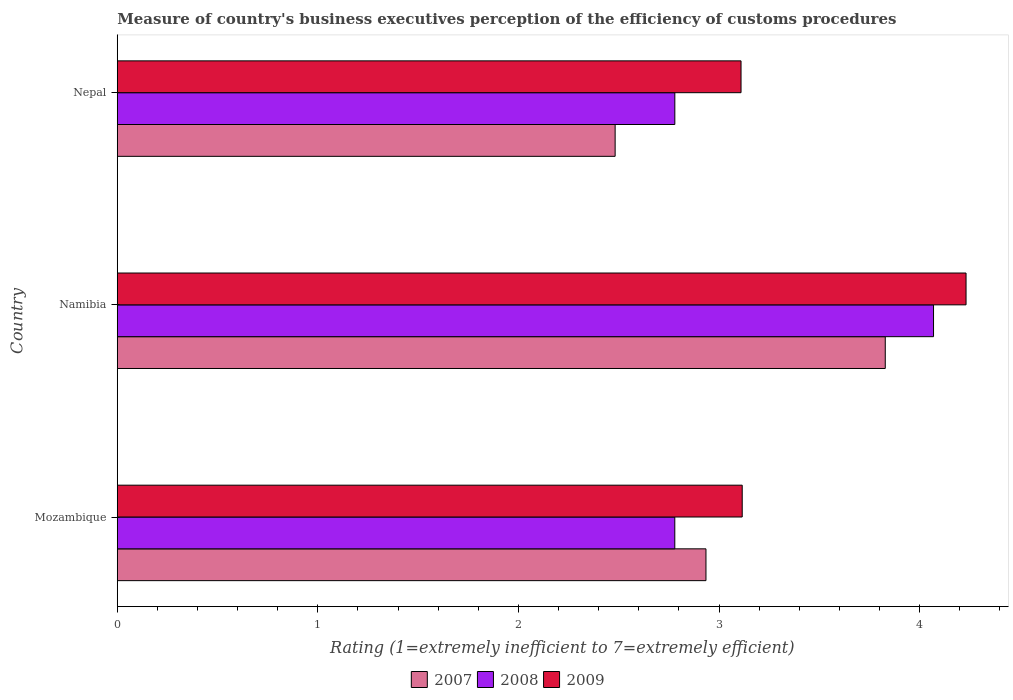How many different coloured bars are there?
Provide a short and direct response. 3. Are the number of bars per tick equal to the number of legend labels?
Provide a short and direct response. Yes. What is the label of the 2nd group of bars from the top?
Your answer should be compact. Namibia. What is the rating of the efficiency of customs procedure in 2009 in Nepal?
Your answer should be very brief. 3.11. Across all countries, what is the maximum rating of the efficiency of customs procedure in 2007?
Provide a succinct answer. 3.83. Across all countries, what is the minimum rating of the efficiency of customs procedure in 2007?
Give a very brief answer. 2.48. In which country was the rating of the efficiency of customs procedure in 2009 maximum?
Keep it short and to the point. Namibia. In which country was the rating of the efficiency of customs procedure in 2008 minimum?
Your answer should be compact. Mozambique. What is the total rating of the efficiency of customs procedure in 2007 in the graph?
Provide a short and direct response. 9.25. What is the difference between the rating of the efficiency of customs procedure in 2008 in Mozambique and that in Namibia?
Give a very brief answer. -1.29. What is the difference between the rating of the efficiency of customs procedure in 2008 in Namibia and the rating of the efficiency of customs procedure in 2009 in Mozambique?
Provide a short and direct response. 0.95. What is the average rating of the efficiency of customs procedure in 2009 per country?
Your response must be concise. 3.49. What is the difference between the rating of the efficiency of customs procedure in 2008 and rating of the efficiency of customs procedure in 2009 in Nepal?
Your answer should be compact. -0.33. What is the ratio of the rating of the efficiency of customs procedure in 2008 in Mozambique to that in Namibia?
Keep it short and to the point. 0.68. What is the difference between the highest and the second highest rating of the efficiency of customs procedure in 2009?
Provide a succinct answer. 1.12. What is the difference between the highest and the lowest rating of the efficiency of customs procedure in 2007?
Your answer should be compact. 1.35. In how many countries, is the rating of the efficiency of customs procedure in 2008 greater than the average rating of the efficiency of customs procedure in 2008 taken over all countries?
Your response must be concise. 1. What does the 2nd bar from the top in Nepal represents?
Offer a terse response. 2008. What does the 1st bar from the bottom in Namibia represents?
Ensure brevity in your answer.  2007. Is it the case that in every country, the sum of the rating of the efficiency of customs procedure in 2008 and rating of the efficiency of customs procedure in 2009 is greater than the rating of the efficiency of customs procedure in 2007?
Keep it short and to the point. Yes. How many bars are there?
Your answer should be compact. 9. How many countries are there in the graph?
Provide a succinct answer. 3. What is the difference between two consecutive major ticks on the X-axis?
Make the answer very short. 1. Does the graph contain grids?
Your answer should be compact. No. Where does the legend appear in the graph?
Give a very brief answer. Bottom center. What is the title of the graph?
Provide a succinct answer. Measure of country's business executives perception of the efficiency of customs procedures. Does "1991" appear as one of the legend labels in the graph?
Your answer should be compact. No. What is the label or title of the X-axis?
Keep it short and to the point. Rating (1=extremely inefficient to 7=extremely efficient). What is the label or title of the Y-axis?
Keep it short and to the point. Country. What is the Rating (1=extremely inefficient to 7=extremely efficient) in 2007 in Mozambique?
Ensure brevity in your answer.  2.93. What is the Rating (1=extremely inefficient to 7=extremely efficient) of 2008 in Mozambique?
Keep it short and to the point. 2.78. What is the Rating (1=extremely inefficient to 7=extremely efficient) of 2009 in Mozambique?
Your answer should be very brief. 3.12. What is the Rating (1=extremely inefficient to 7=extremely efficient) of 2007 in Namibia?
Provide a short and direct response. 3.83. What is the Rating (1=extremely inefficient to 7=extremely efficient) in 2008 in Namibia?
Offer a very short reply. 4.07. What is the Rating (1=extremely inefficient to 7=extremely efficient) in 2009 in Namibia?
Keep it short and to the point. 4.23. What is the Rating (1=extremely inefficient to 7=extremely efficient) of 2007 in Nepal?
Offer a terse response. 2.48. What is the Rating (1=extremely inefficient to 7=extremely efficient) of 2008 in Nepal?
Your answer should be compact. 2.78. What is the Rating (1=extremely inefficient to 7=extremely efficient) in 2009 in Nepal?
Make the answer very short. 3.11. Across all countries, what is the maximum Rating (1=extremely inefficient to 7=extremely efficient) in 2007?
Make the answer very short. 3.83. Across all countries, what is the maximum Rating (1=extremely inefficient to 7=extremely efficient) in 2008?
Your answer should be compact. 4.07. Across all countries, what is the maximum Rating (1=extremely inefficient to 7=extremely efficient) of 2009?
Offer a very short reply. 4.23. Across all countries, what is the minimum Rating (1=extremely inefficient to 7=extremely efficient) in 2007?
Provide a short and direct response. 2.48. Across all countries, what is the minimum Rating (1=extremely inefficient to 7=extremely efficient) in 2008?
Offer a terse response. 2.78. Across all countries, what is the minimum Rating (1=extremely inefficient to 7=extremely efficient) in 2009?
Make the answer very short. 3.11. What is the total Rating (1=extremely inefficient to 7=extremely efficient) of 2007 in the graph?
Provide a succinct answer. 9.25. What is the total Rating (1=extremely inefficient to 7=extremely efficient) of 2008 in the graph?
Offer a terse response. 9.63. What is the total Rating (1=extremely inefficient to 7=extremely efficient) of 2009 in the graph?
Offer a terse response. 10.46. What is the difference between the Rating (1=extremely inefficient to 7=extremely efficient) in 2007 in Mozambique and that in Namibia?
Make the answer very short. -0.89. What is the difference between the Rating (1=extremely inefficient to 7=extremely efficient) of 2008 in Mozambique and that in Namibia?
Offer a very short reply. -1.29. What is the difference between the Rating (1=extremely inefficient to 7=extremely efficient) in 2009 in Mozambique and that in Namibia?
Provide a short and direct response. -1.12. What is the difference between the Rating (1=extremely inefficient to 7=extremely efficient) of 2007 in Mozambique and that in Nepal?
Offer a very short reply. 0.45. What is the difference between the Rating (1=extremely inefficient to 7=extremely efficient) in 2008 in Mozambique and that in Nepal?
Make the answer very short. -0. What is the difference between the Rating (1=extremely inefficient to 7=extremely efficient) in 2009 in Mozambique and that in Nepal?
Ensure brevity in your answer.  0.01. What is the difference between the Rating (1=extremely inefficient to 7=extremely efficient) of 2007 in Namibia and that in Nepal?
Offer a very short reply. 1.35. What is the difference between the Rating (1=extremely inefficient to 7=extremely efficient) of 2008 in Namibia and that in Nepal?
Your response must be concise. 1.29. What is the difference between the Rating (1=extremely inefficient to 7=extremely efficient) in 2009 in Namibia and that in Nepal?
Your response must be concise. 1.12. What is the difference between the Rating (1=extremely inefficient to 7=extremely efficient) in 2007 in Mozambique and the Rating (1=extremely inefficient to 7=extremely efficient) in 2008 in Namibia?
Give a very brief answer. -1.13. What is the difference between the Rating (1=extremely inefficient to 7=extremely efficient) of 2007 in Mozambique and the Rating (1=extremely inefficient to 7=extremely efficient) of 2009 in Namibia?
Your response must be concise. -1.3. What is the difference between the Rating (1=extremely inefficient to 7=extremely efficient) in 2008 in Mozambique and the Rating (1=extremely inefficient to 7=extremely efficient) in 2009 in Namibia?
Offer a very short reply. -1.45. What is the difference between the Rating (1=extremely inefficient to 7=extremely efficient) of 2007 in Mozambique and the Rating (1=extremely inefficient to 7=extremely efficient) of 2008 in Nepal?
Keep it short and to the point. 0.16. What is the difference between the Rating (1=extremely inefficient to 7=extremely efficient) in 2007 in Mozambique and the Rating (1=extremely inefficient to 7=extremely efficient) in 2009 in Nepal?
Keep it short and to the point. -0.17. What is the difference between the Rating (1=extremely inefficient to 7=extremely efficient) of 2008 in Mozambique and the Rating (1=extremely inefficient to 7=extremely efficient) of 2009 in Nepal?
Make the answer very short. -0.33. What is the difference between the Rating (1=extremely inefficient to 7=extremely efficient) in 2007 in Namibia and the Rating (1=extremely inefficient to 7=extremely efficient) in 2008 in Nepal?
Provide a short and direct response. 1.05. What is the difference between the Rating (1=extremely inefficient to 7=extremely efficient) of 2007 in Namibia and the Rating (1=extremely inefficient to 7=extremely efficient) of 2009 in Nepal?
Provide a succinct answer. 0.72. What is the difference between the Rating (1=extremely inefficient to 7=extremely efficient) in 2008 in Namibia and the Rating (1=extremely inefficient to 7=extremely efficient) in 2009 in Nepal?
Offer a terse response. 0.96. What is the average Rating (1=extremely inefficient to 7=extremely efficient) of 2007 per country?
Offer a very short reply. 3.08. What is the average Rating (1=extremely inefficient to 7=extremely efficient) in 2008 per country?
Keep it short and to the point. 3.21. What is the average Rating (1=extremely inefficient to 7=extremely efficient) in 2009 per country?
Provide a short and direct response. 3.49. What is the difference between the Rating (1=extremely inefficient to 7=extremely efficient) of 2007 and Rating (1=extremely inefficient to 7=extremely efficient) of 2008 in Mozambique?
Keep it short and to the point. 0.16. What is the difference between the Rating (1=extremely inefficient to 7=extremely efficient) of 2007 and Rating (1=extremely inefficient to 7=extremely efficient) of 2009 in Mozambique?
Make the answer very short. -0.18. What is the difference between the Rating (1=extremely inefficient to 7=extremely efficient) of 2008 and Rating (1=extremely inefficient to 7=extremely efficient) of 2009 in Mozambique?
Offer a terse response. -0.34. What is the difference between the Rating (1=extremely inefficient to 7=extremely efficient) in 2007 and Rating (1=extremely inefficient to 7=extremely efficient) in 2008 in Namibia?
Ensure brevity in your answer.  -0.24. What is the difference between the Rating (1=extremely inefficient to 7=extremely efficient) in 2007 and Rating (1=extremely inefficient to 7=extremely efficient) in 2009 in Namibia?
Offer a terse response. -0.4. What is the difference between the Rating (1=extremely inefficient to 7=extremely efficient) of 2008 and Rating (1=extremely inefficient to 7=extremely efficient) of 2009 in Namibia?
Keep it short and to the point. -0.16. What is the difference between the Rating (1=extremely inefficient to 7=extremely efficient) in 2007 and Rating (1=extremely inefficient to 7=extremely efficient) in 2008 in Nepal?
Your answer should be compact. -0.3. What is the difference between the Rating (1=extremely inefficient to 7=extremely efficient) in 2007 and Rating (1=extremely inefficient to 7=extremely efficient) in 2009 in Nepal?
Provide a succinct answer. -0.63. What is the difference between the Rating (1=extremely inefficient to 7=extremely efficient) of 2008 and Rating (1=extremely inefficient to 7=extremely efficient) of 2009 in Nepal?
Keep it short and to the point. -0.33. What is the ratio of the Rating (1=extremely inefficient to 7=extremely efficient) in 2007 in Mozambique to that in Namibia?
Give a very brief answer. 0.77. What is the ratio of the Rating (1=extremely inefficient to 7=extremely efficient) in 2008 in Mozambique to that in Namibia?
Make the answer very short. 0.68. What is the ratio of the Rating (1=extremely inefficient to 7=extremely efficient) of 2009 in Mozambique to that in Namibia?
Give a very brief answer. 0.74. What is the ratio of the Rating (1=extremely inefficient to 7=extremely efficient) of 2007 in Mozambique to that in Nepal?
Your answer should be very brief. 1.18. What is the ratio of the Rating (1=extremely inefficient to 7=extremely efficient) of 2007 in Namibia to that in Nepal?
Provide a short and direct response. 1.54. What is the ratio of the Rating (1=extremely inefficient to 7=extremely efficient) in 2008 in Namibia to that in Nepal?
Give a very brief answer. 1.46. What is the ratio of the Rating (1=extremely inefficient to 7=extremely efficient) of 2009 in Namibia to that in Nepal?
Ensure brevity in your answer.  1.36. What is the difference between the highest and the second highest Rating (1=extremely inefficient to 7=extremely efficient) in 2007?
Your answer should be very brief. 0.89. What is the difference between the highest and the second highest Rating (1=extremely inefficient to 7=extremely efficient) in 2008?
Ensure brevity in your answer.  1.29. What is the difference between the highest and the second highest Rating (1=extremely inefficient to 7=extremely efficient) in 2009?
Make the answer very short. 1.12. What is the difference between the highest and the lowest Rating (1=extremely inefficient to 7=extremely efficient) of 2007?
Your response must be concise. 1.35. What is the difference between the highest and the lowest Rating (1=extremely inefficient to 7=extremely efficient) of 2008?
Ensure brevity in your answer.  1.29. What is the difference between the highest and the lowest Rating (1=extremely inefficient to 7=extremely efficient) of 2009?
Offer a very short reply. 1.12. 